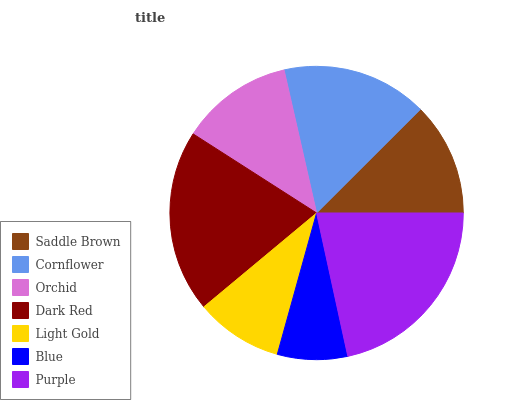Is Blue the minimum?
Answer yes or no. Yes. Is Purple the maximum?
Answer yes or no. Yes. Is Cornflower the minimum?
Answer yes or no. No. Is Cornflower the maximum?
Answer yes or no. No. Is Cornflower greater than Saddle Brown?
Answer yes or no. Yes. Is Saddle Brown less than Cornflower?
Answer yes or no. Yes. Is Saddle Brown greater than Cornflower?
Answer yes or no. No. Is Cornflower less than Saddle Brown?
Answer yes or no. No. Is Saddle Brown the high median?
Answer yes or no. Yes. Is Saddle Brown the low median?
Answer yes or no. Yes. Is Light Gold the high median?
Answer yes or no. No. Is Orchid the low median?
Answer yes or no. No. 